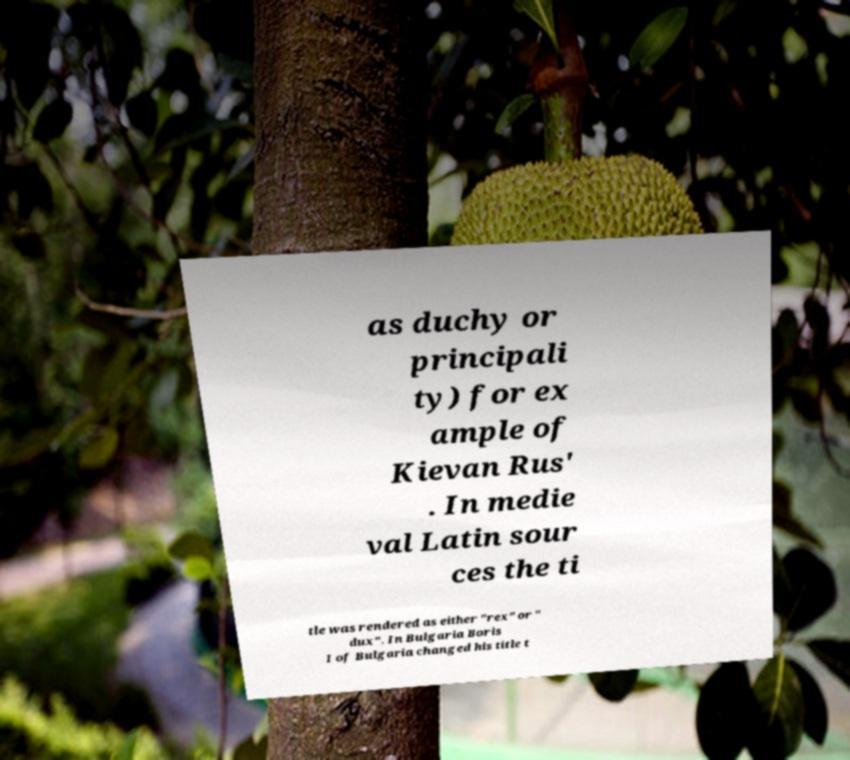Please identify and transcribe the text found in this image. as duchy or principali ty) for ex ample of Kievan Rus' . In medie val Latin sour ces the ti tle was rendered as either "rex" or " dux". In Bulgaria Boris I of Bulgaria changed his title t 